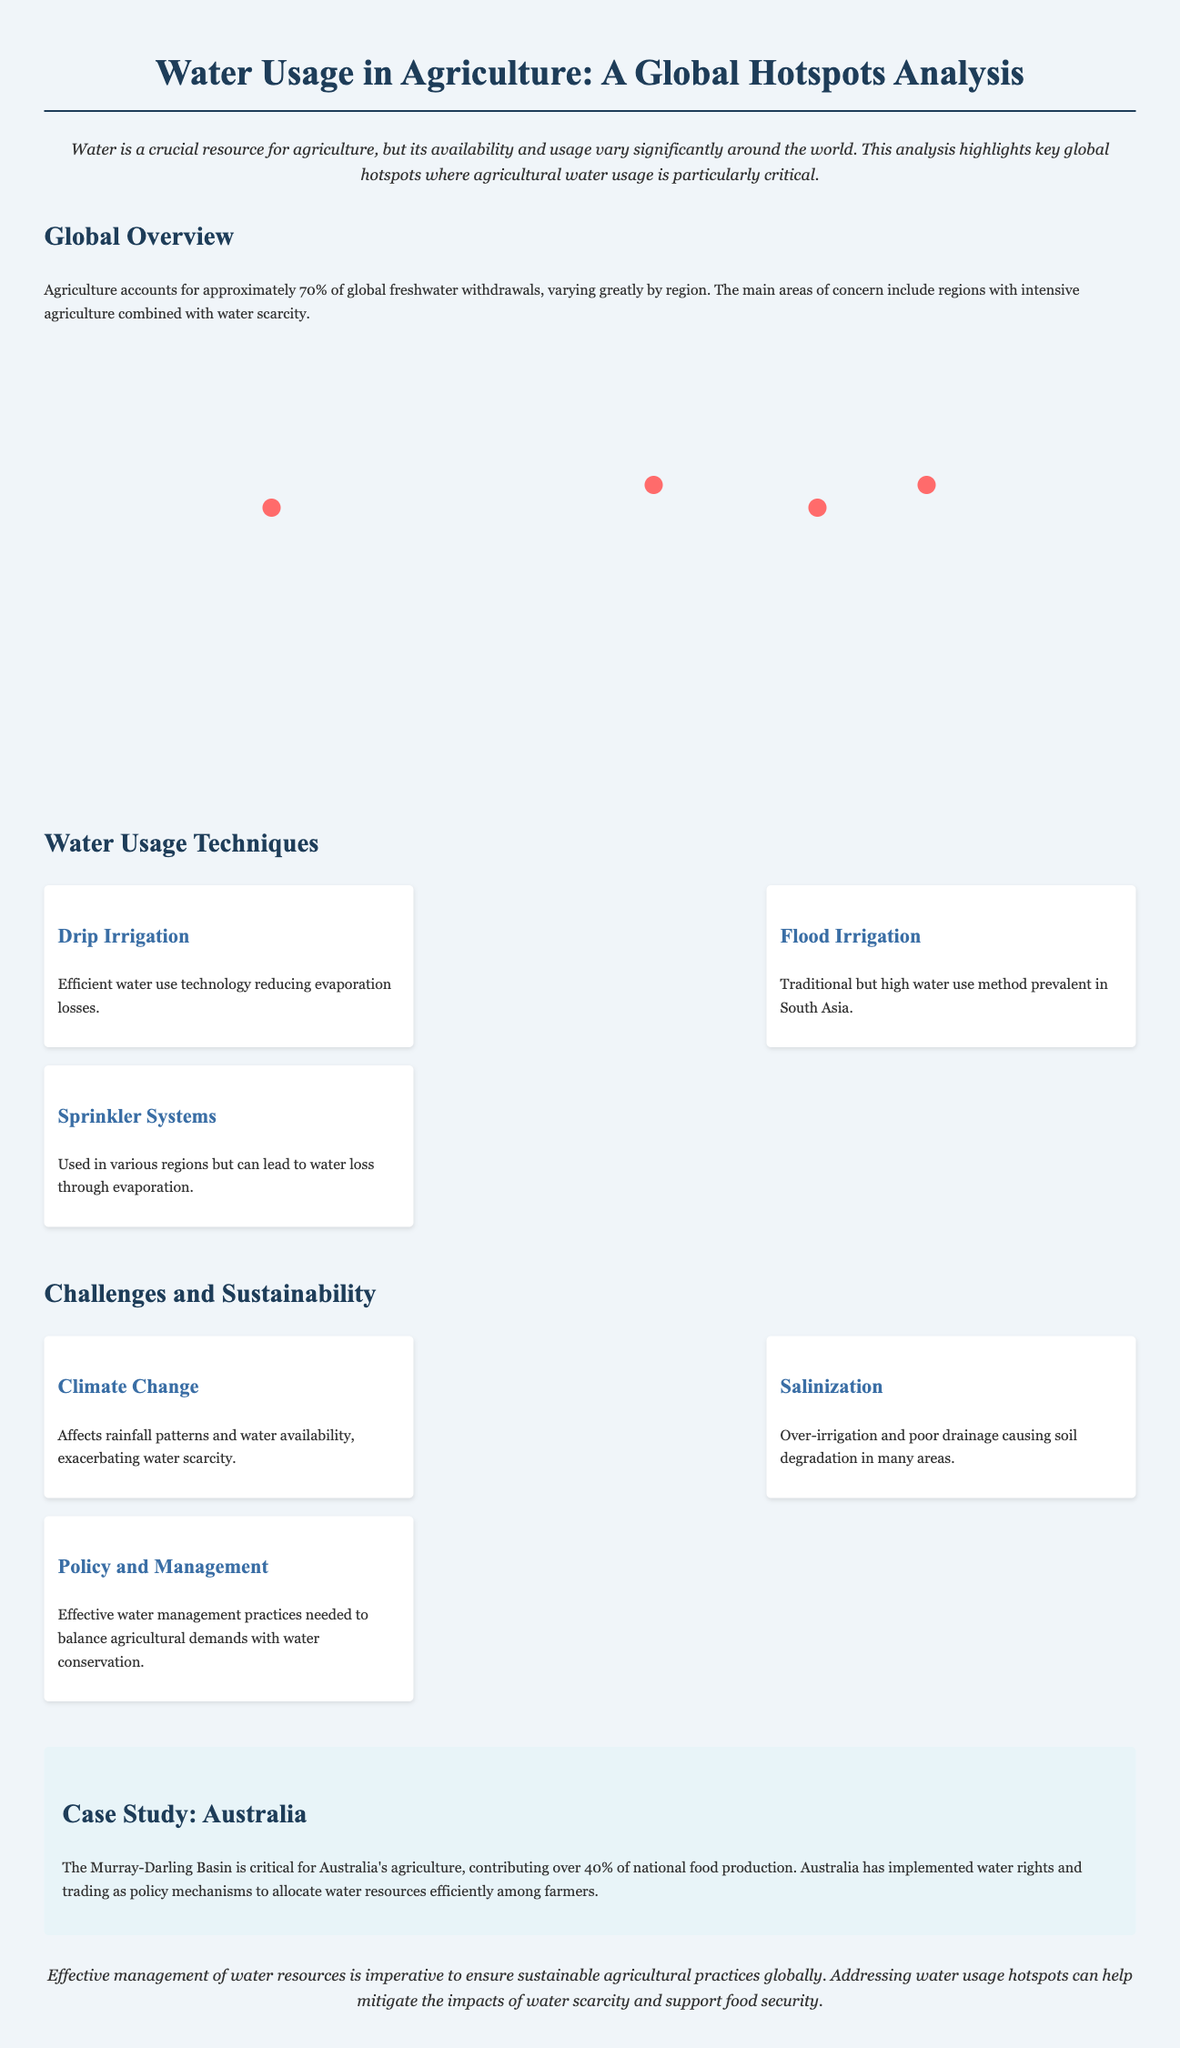what percentage of global freshwater withdrawals does agriculture account for? The document states that agriculture accounts for approximately 70% of global freshwater withdrawals.
Answer: 70% which country represents around 20% of global agricultural water withdrawals? The infographic highlights India as representing around 20% of global agricultural water withdrawals.
Answer: India what are the two main crops mentioned as causes of high water stress in Punjab and Haryana? The document states that intensive rice and wheat farming causes high water stress in these regions.
Answer: Rice and wheat how does the North China Plain primarily suffer from water issues? The document explains that over-extraction of groundwater for wheat and maize production leads to water issues in the North China Plain.
Answer: Over-extraction of groundwater what is the primary water usage technique that reduces evaporation losses? The document lists drip irrigation as a technique that effectively reduces evaporation losses.
Answer: Drip irrigation which region utilizes pivot irrigation for wheat in desert conditions? The infographic notes that Saudi Arabia uses pivot irrigation for wheat in desert conditions.
Answer: Saudi Arabia what proportion of freshwater does agriculture use in the United States? According to the document, the United States uses around 40% of its freshwater withdrawals for agriculture.
Answer: 40% what is the main challenge mentioned that exacerbates water scarcity? Climate change is identified as a significant challenge that affects rainfall patterns and exacerbates water scarcity.
Answer: Climate change how much of Australia's national food production comes from the Murray-Darling Basin? The document states that the Murray-Darling Basin contributes over 40% of Australia's national food production.
Answer: 40% 